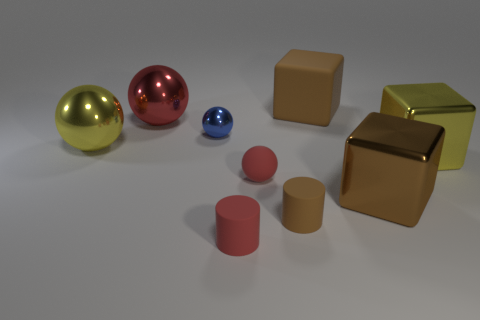There is a big thing on the left side of the large sphere that is right of the yellow metal object to the left of the big brown rubber cube; what shape is it?
Provide a succinct answer. Sphere. What shape is the small red object that is in front of the large brown cube right of the rubber block?
Your answer should be very brief. Cylinder. Is there a blue cylinder made of the same material as the big yellow sphere?
Make the answer very short. No. What size is the metal cube that is the same color as the large matte object?
Give a very brief answer. Large. How many yellow objects are tiny spheres or big metal things?
Give a very brief answer. 2. Is there a metal cylinder that has the same color as the rubber block?
Make the answer very short. No. There is a brown object that is the same material as the large red object; what is its size?
Provide a succinct answer. Large. What number of cylinders are blue objects or matte things?
Provide a short and direct response. 2. Is the number of small red objects greater than the number of matte things?
Provide a short and direct response. No. What number of purple metal cylinders are the same size as the brown cylinder?
Make the answer very short. 0. 